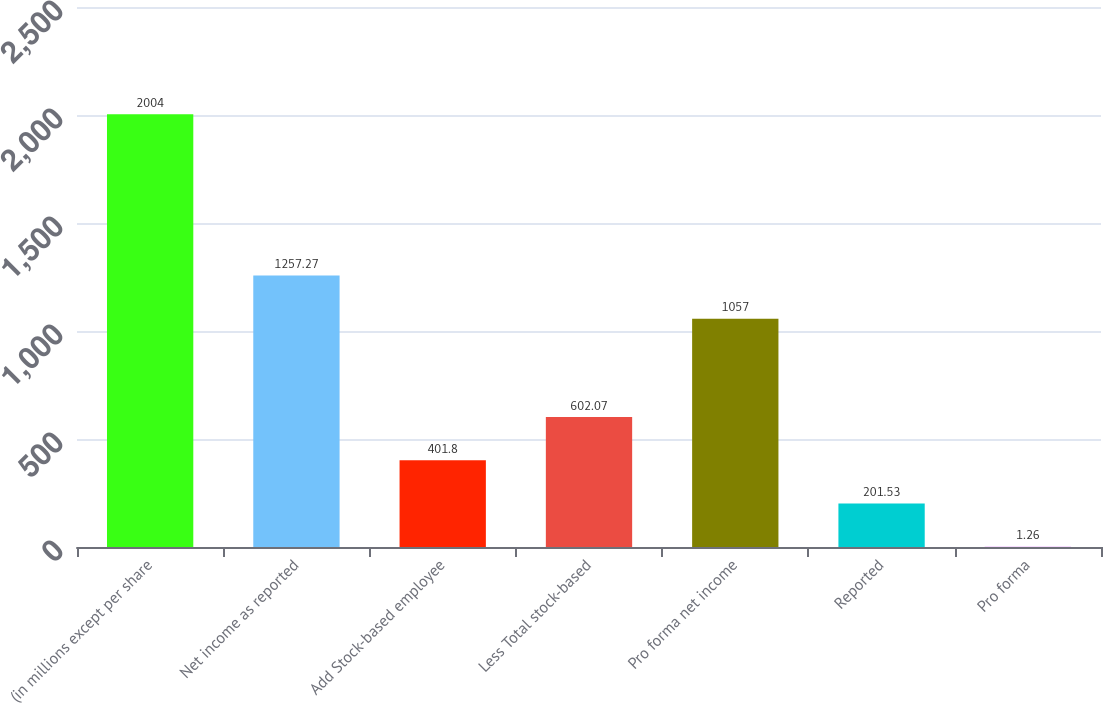Convert chart. <chart><loc_0><loc_0><loc_500><loc_500><bar_chart><fcel>(in millions except per share<fcel>Net income as reported<fcel>Add Stock-based employee<fcel>Less Total stock-based<fcel>Pro forma net income<fcel>Reported<fcel>Pro forma<nl><fcel>2004<fcel>1257.27<fcel>401.8<fcel>602.07<fcel>1057<fcel>201.53<fcel>1.26<nl></chart> 